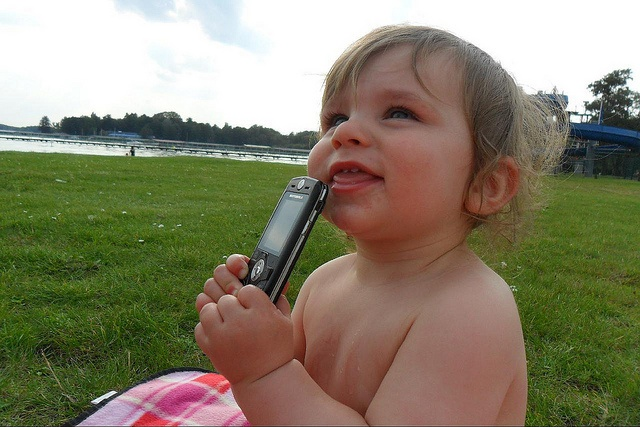Describe the objects in this image and their specific colors. I can see people in white, gray, brown, and maroon tones and cell phone in white, black, darkgray, and gray tones in this image. 